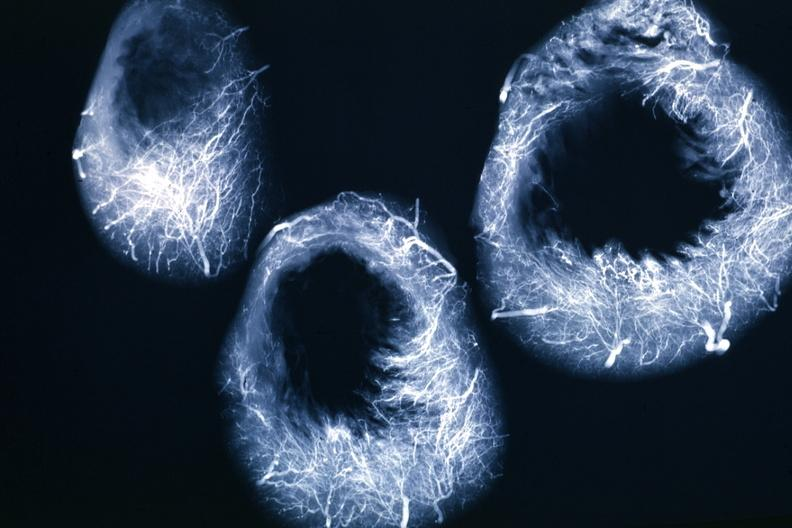s beckwith-wiedemann syndrome present?
Answer the question using a single word or phrase. No 